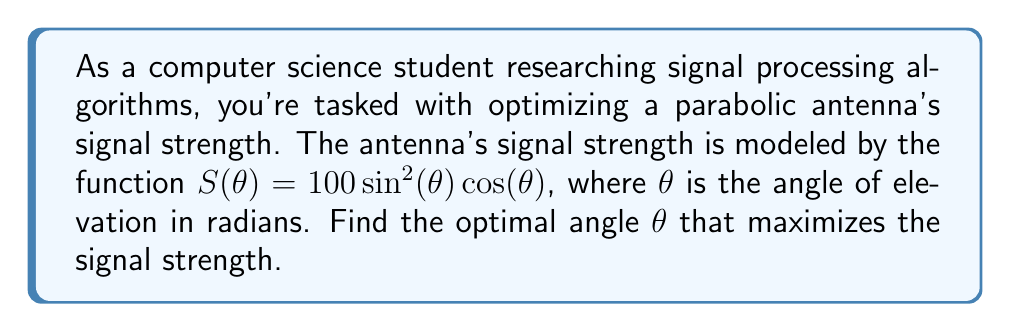Give your solution to this math problem. To find the optimal angle, we need to maximize the function $S(\theta) = 100 \sin^2(\theta) \cos(\theta)$. This can be done by finding the critical points of the function and evaluating them.

1. First, let's find the derivative of $S(\theta)$ using the product rule and chain rule:

   $$\frac{dS}{d\theta} = 100 \cdot (2\sin(\theta)\cos^2(\theta) - \sin^3(\theta))$$

2. Set the derivative equal to zero to find the critical points:

   $$100 \cdot (2\sin(\theta)\cos^2(\theta) - \sin^3(\theta)) = 0$$
   $$2\sin(\theta)\cos^2(\theta) - \sin^3(\theta) = 0$$
   $$\sin(\theta)(2\cos^2(\theta) - \sin^2(\theta)) = 0$$

3. Solve the equation:
   - Case 1: $\sin(\theta) = 0$ gives $\theta = 0, \pi, 2\pi, ...$
   - Case 2: $2\cos^2(\theta) - \sin^2(\theta) = 0$
     
     Using the identity $\sin^2(\theta) + \cos^2(\theta) = 1$, we can rewrite this as:
     $$2\cos^2(\theta) - (1 - \cos^2(\theta)) = 0$$
     $$3\cos^2(\theta) - 1 = 0$$
     $$\cos^2(\theta) = \frac{1}{3}$$
     $$\cos(\theta) = \pm\frac{1}{\sqrt{3}}$$

     The positive solution in the first quadrant is:
     $$\theta = \arccos(\frac{1}{\sqrt{3}}) \approx 0.9553 \text{ radians} \approx 54.74^\circ$$

4. Evaluate $S(\theta)$ at these critical points:
   - At $\theta = 0$ or $\pi$: $S(0) = S(\pi) = 0$
   - At $\theta = \arccos(\frac{1}{\sqrt{3}})$:
     $$S(\arccos(\frac{1}{\sqrt{3}})) = 100 \cdot (\frac{2}{3})^{3/2} \approx 54.43$$

5. The maximum value occurs at $\theta = \arccos(\frac{1}{\sqrt{3}})$.

Therefore, the optimal angle to maximize signal strength is $\arccos(\frac{1}{\sqrt{3}})$ radians or approximately 54.74°.
Answer: The optimal angle $\theta$ that maximizes the signal strength is $\arccos(\frac{1}{\sqrt{3}})$ radians or approximately 54.74°. 